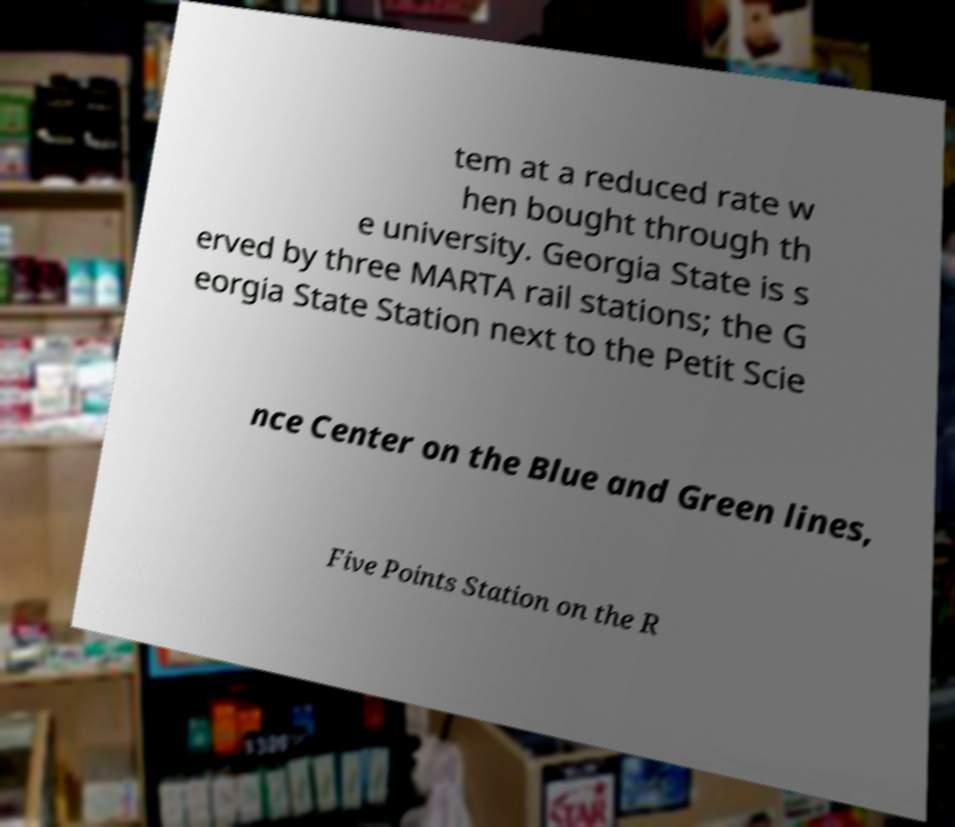What messages or text are displayed in this image? I need them in a readable, typed format. tem at a reduced rate w hen bought through th e university. Georgia State is s erved by three MARTA rail stations; the G eorgia State Station next to the Petit Scie nce Center on the Blue and Green lines, Five Points Station on the R 